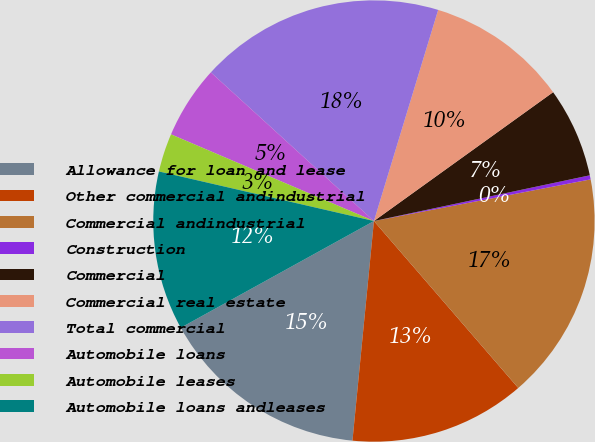Convert chart. <chart><loc_0><loc_0><loc_500><loc_500><pie_chart><fcel>Allowance for loan and lease<fcel>Other commercial andindustrial<fcel>Commercial andindustrial<fcel>Construction<fcel>Commercial<fcel>Commercial real estate<fcel>Total commercial<fcel>Automobile loans<fcel>Automobile leases<fcel>Automobile loans andleases<nl><fcel>15.42%<fcel>12.9%<fcel>16.68%<fcel>0.3%<fcel>6.6%<fcel>10.38%<fcel>17.94%<fcel>5.34%<fcel>2.82%<fcel>11.64%<nl></chart> 